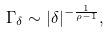Convert formula to latex. <formula><loc_0><loc_0><loc_500><loc_500>\Gamma _ { \delta } \sim | \delta | ^ { - \frac { 1 } { \rho - 1 } } ,</formula> 